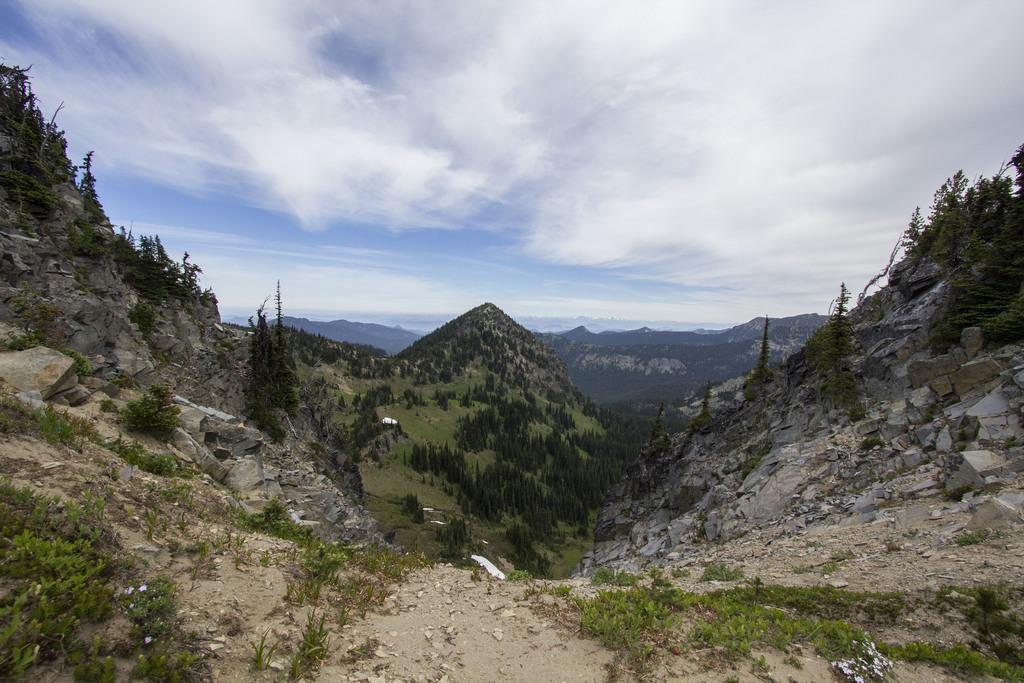What type of natural elements can be seen in the image? There are trees, hills, and rocks in the image. What is visible in the sky in the image? There are clouds in the image. What type of lace can be seen on the trees in the image? There is no lace present on the trees in the image; they are natural elements without any human-made additions. 